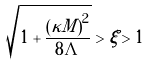Convert formula to latex. <formula><loc_0><loc_0><loc_500><loc_500>\sqrt { 1 + \frac { \left ( \kappa M \right ) ^ { 2 } } { 8 \Lambda } } > \xi > 1</formula> 